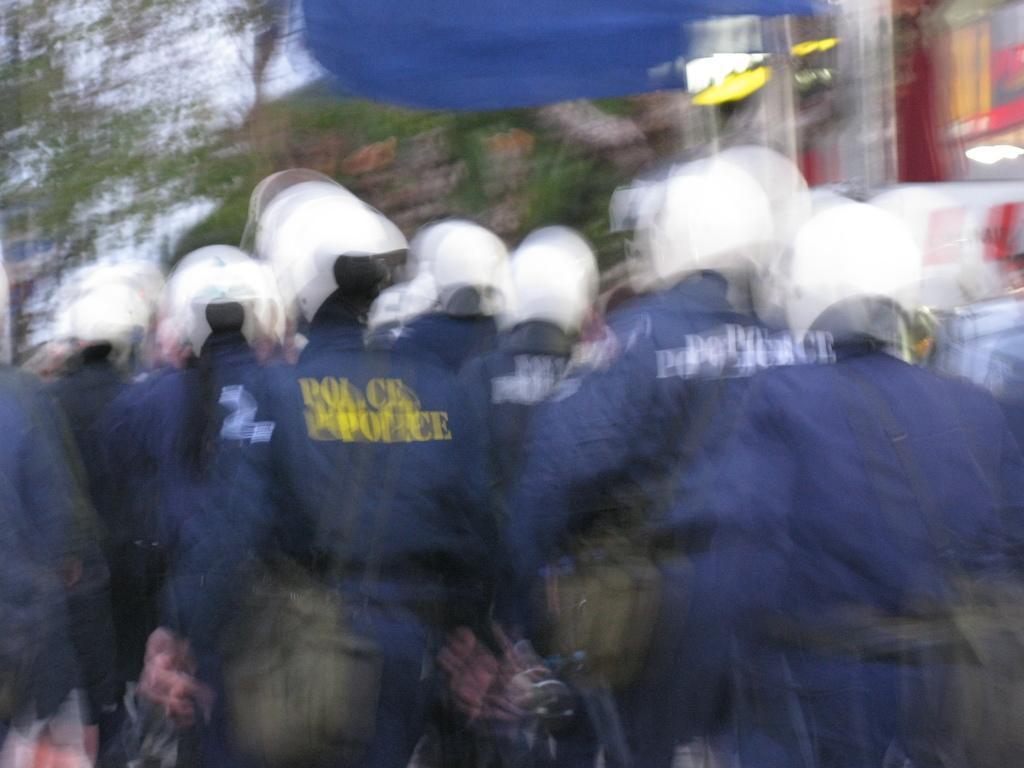Could you give a brief overview of what you see in this image? As we can see in the image there is a building and group of people standing in the front. The image is little blurred. 